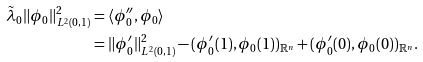<formula> <loc_0><loc_0><loc_500><loc_500>\tilde { \lambda } _ { 0 } \| \phi _ { 0 } \| _ { L ^ { 2 } ( 0 , 1 ) } ^ { 2 } & = \langle \phi _ { 0 } ^ { \prime \prime } , \phi _ { 0 } \rangle \\ & = \| \phi _ { 0 } ^ { \prime } \| _ { L ^ { 2 } ( 0 , 1 ) } ^ { 2 } - ( \phi _ { 0 } ^ { \prime } ( 1 ) , \phi _ { 0 } ( 1 ) ) _ { \mathbb { R } ^ { n } } + ( \phi _ { 0 } ^ { \prime } ( 0 ) , \phi _ { 0 } ( 0 ) ) _ { \mathbb { R } ^ { n } } .</formula> 